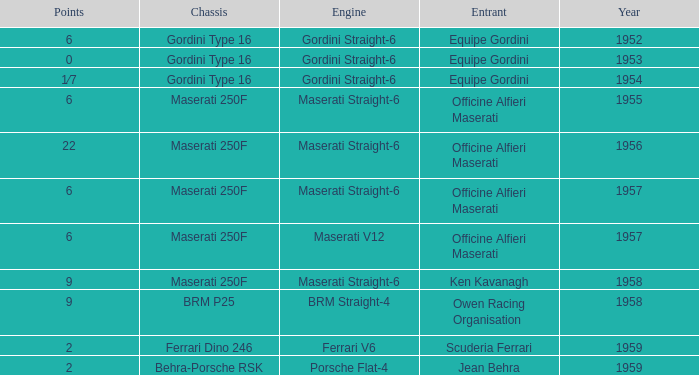What year engine does a ferrari v6 have? 1959.0. 